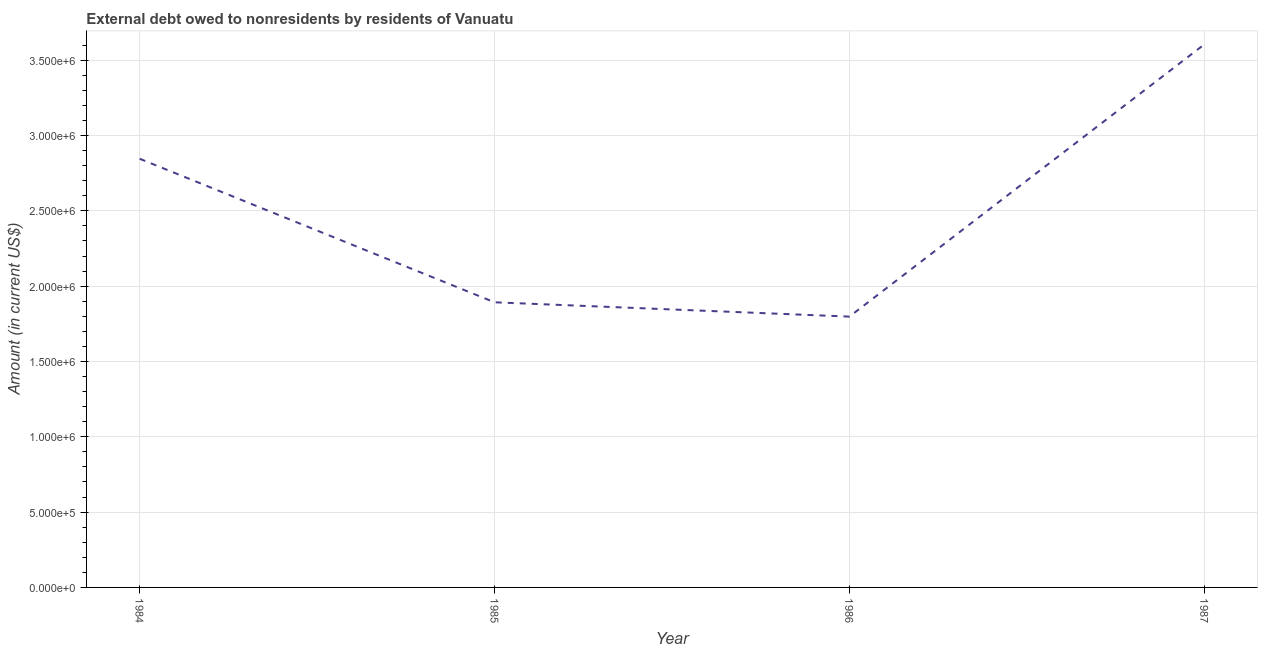What is the debt in 1986?
Make the answer very short. 1.80e+06. Across all years, what is the maximum debt?
Your response must be concise. 3.60e+06. Across all years, what is the minimum debt?
Keep it short and to the point. 1.80e+06. In which year was the debt maximum?
Your answer should be very brief. 1987. What is the sum of the debt?
Make the answer very short. 1.01e+07. What is the difference between the debt in 1985 and 1986?
Your response must be concise. 9.50e+04. What is the average debt per year?
Your answer should be compact. 2.54e+06. What is the median debt?
Offer a very short reply. 2.37e+06. Do a majority of the years between 1987 and 1985 (inclusive) have debt greater than 1000000 US$?
Ensure brevity in your answer.  No. What is the ratio of the debt in 1986 to that in 1987?
Your response must be concise. 0.5. Is the debt in 1984 less than that in 1985?
Offer a terse response. No. Is the difference between the debt in 1986 and 1987 greater than the difference between any two years?
Provide a short and direct response. Yes. What is the difference between the highest and the second highest debt?
Provide a short and direct response. 7.59e+05. Is the sum of the debt in 1984 and 1985 greater than the maximum debt across all years?
Your response must be concise. Yes. What is the difference between the highest and the lowest debt?
Give a very brief answer. 1.81e+06. In how many years, is the debt greater than the average debt taken over all years?
Your response must be concise. 2. Does the debt monotonically increase over the years?
Your response must be concise. No. Does the graph contain any zero values?
Your response must be concise. No. Does the graph contain grids?
Your answer should be very brief. Yes. What is the title of the graph?
Your answer should be compact. External debt owed to nonresidents by residents of Vanuatu. What is the label or title of the X-axis?
Give a very brief answer. Year. What is the Amount (in current US$) in 1984?
Your response must be concise. 2.85e+06. What is the Amount (in current US$) in 1985?
Your response must be concise. 1.89e+06. What is the Amount (in current US$) of 1986?
Your answer should be compact. 1.80e+06. What is the Amount (in current US$) in 1987?
Ensure brevity in your answer.  3.60e+06. What is the difference between the Amount (in current US$) in 1984 and 1985?
Keep it short and to the point. 9.53e+05. What is the difference between the Amount (in current US$) in 1984 and 1986?
Provide a short and direct response. 1.05e+06. What is the difference between the Amount (in current US$) in 1984 and 1987?
Give a very brief answer. -7.59e+05. What is the difference between the Amount (in current US$) in 1985 and 1986?
Ensure brevity in your answer.  9.50e+04. What is the difference between the Amount (in current US$) in 1985 and 1987?
Your answer should be very brief. -1.71e+06. What is the difference between the Amount (in current US$) in 1986 and 1987?
Ensure brevity in your answer.  -1.81e+06. What is the ratio of the Amount (in current US$) in 1984 to that in 1985?
Provide a short and direct response. 1.5. What is the ratio of the Amount (in current US$) in 1984 to that in 1986?
Your response must be concise. 1.58. What is the ratio of the Amount (in current US$) in 1984 to that in 1987?
Keep it short and to the point. 0.79. What is the ratio of the Amount (in current US$) in 1985 to that in 1986?
Your answer should be compact. 1.05. What is the ratio of the Amount (in current US$) in 1985 to that in 1987?
Give a very brief answer. 0.53. What is the ratio of the Amount (in current US$) in 1986 to that in 1987?
Provide a short and direct response. 0.5. 